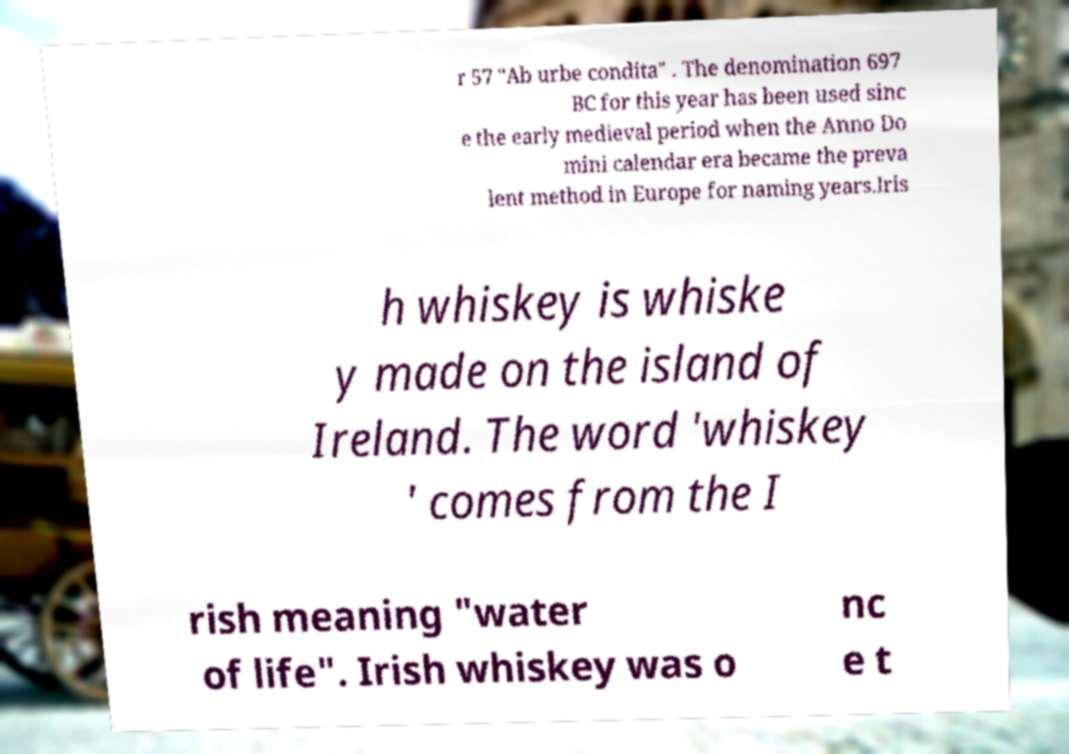Could you assist in decoding the text presented in this image and type it out clearly? r 57 "Ab urbe condita" . The denomination 697 BC for this year has been used sinc e the early medieval period when the Anno Do mini calendar era became the preva lent method in Europe for naming years.Iris h whiskey is whiske y made on the island of Ireland. The word 'whiskey ' comes from the I rish meaning "water of life". Irish whiskey was o nc e t 